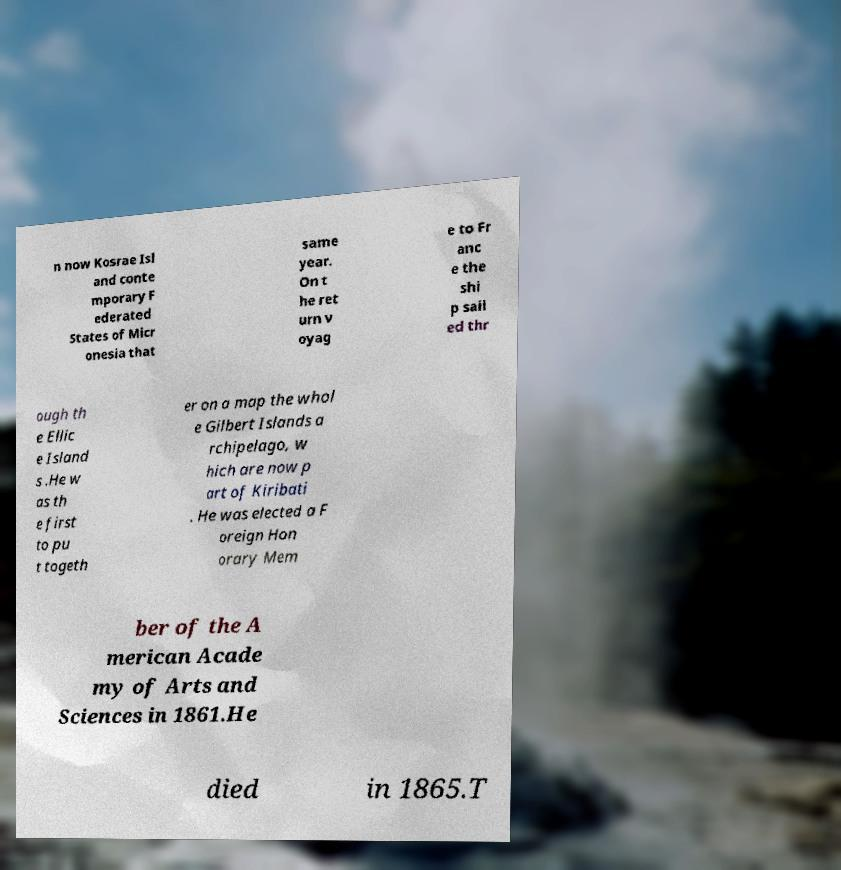Please identify and transcribe the text found in this image. n now Kosrae Isl and conte mporary F ederated States of Micr onesia that same year. On t he ret urn v oyag e to Fr anc e the shi p sail ed thr ough th e Ellic e Island s .He w as th e first to pu t togeth er on a map the whol e Gilbert Islands a rchipelago, w hich are now p art of Kiribati . He was elected a F oreign Hon orary Mem ber of the A merican Acade my of Arts and Sciences in 1861.He died in 1865.T 